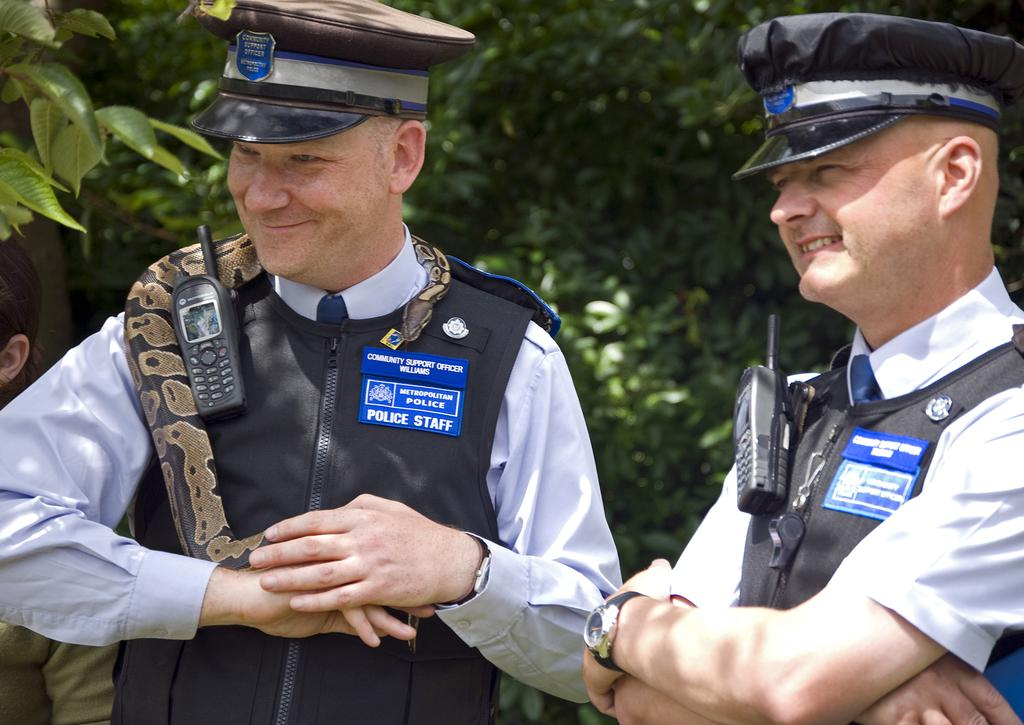<image>
Relay a brief, clear account of the picture shown. a man from the police staff with another man from the same staff 